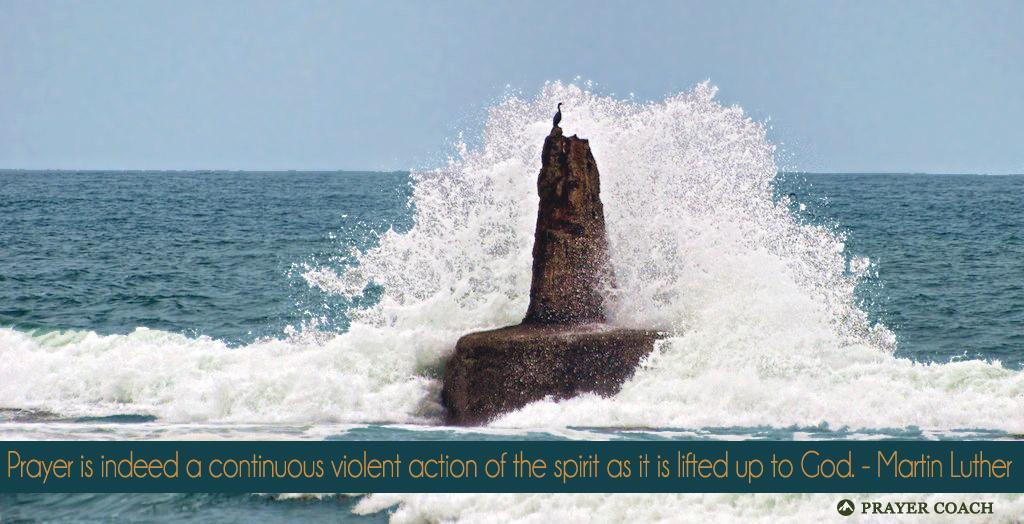Can you describe this image briefly? In the center of the image there is a rockin on top of it there is a bird. Behind the rock there is water. In the background of the image there is sky. At the bottom of the image there is some text written on it. 